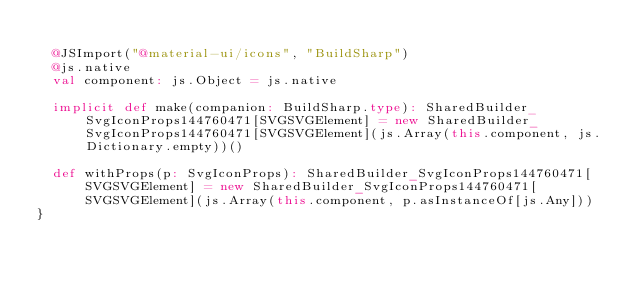<code> <loc_0><loc_0><loc_500><loc_500><_Scala_>  
  @JSImport("@material-ui/icons", "BuildSharp")
  @js.native
  val component: js.Object = js.native
  
  implicit def make(companion: BuildSharp.type): SharedBuilder_SvgIconProps144760471[SVGSVGElement] = new SharedBuilder_SvgIconProps144760471[SVGSVGElement](js.Array(this.component, js.Dictionary.empty))()
  
  def withProps(p: SvgIconProps): SharedBuilder_SvgIconProps144760471[SVGSVGElement] = new SharedBuilder_SvgIconProps144760471[SVGSVGElement](js.Array(this.component, p.asInstanceOf[js.Any]))
}
</code> 